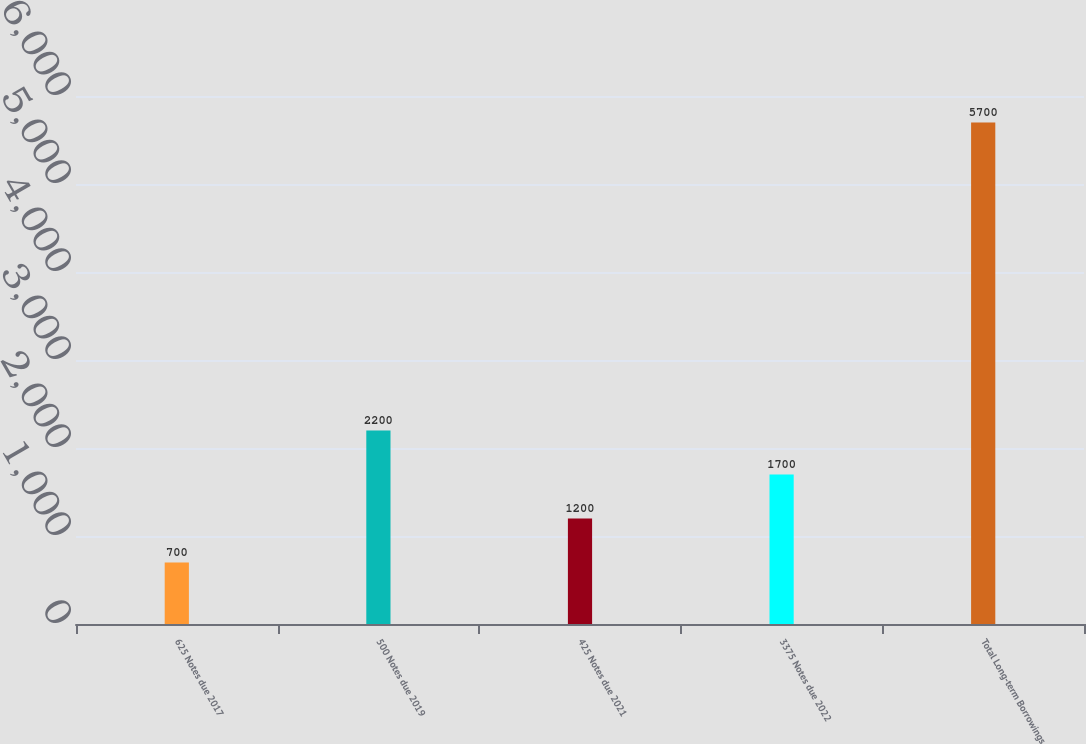Convert chart to OTSL. <chart><loc_0><loc_0><loc_500><loc_500><bar_chart><fcel>625 Notes due 2017<fcel>500 Notes due 2019<fcel>425 Notes due 2021<fcel>3375 Notes due 2022<fcel>Total Long-term Borrowings<nl><fcel>700<fcel>2200<fcel>1200<fcel>1700<fcel>5700<nl></chart> 